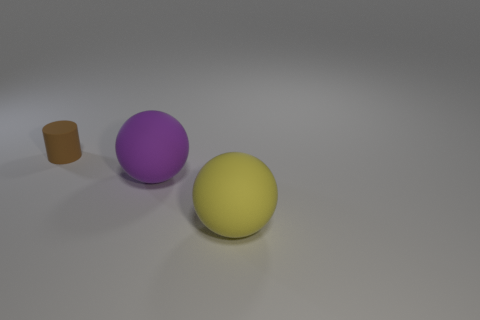What material is the thing on the left side of the large rubber object that is on the left side of the big thing that is in front of the purple thing?
Ensure brevity in your answer.  Rubber. Is the material of the large yellow sphere the same as the sphere that is behind the big yellow matte thing?
Offer a very short reply. Yes. Is the number of matte objects that are behind the tiny brown rubber thing less than the number of small brown objects that are on the right side of the yellow thing?
Keep it short and to the point. No. How many things are made of the same material as the yellow sphere?
Your answer should be very brief. 2. There is a rubber thing in front of the matte sphere behind the big yellow rubber object; are there any rubber spheres behind it?
Keep it short and to the point. Yes. What number of cylinders are small yellow metallic things or tiny things?
Offer a terse response. 1. Is the shape of the purple rubber thing the same as the small matte object behind the big purple rubber ball?
Your response must be concise. No. Are there fewer things in front of the big yellow matte ball than gray rubber things?
Offer a terse response. No. There is a small object; are there any matte things in front of it?
Offer a very short reply. Yes. Are there any other large things of the same shape as the large yellow object?
Keep it short and to the point. Yes. 